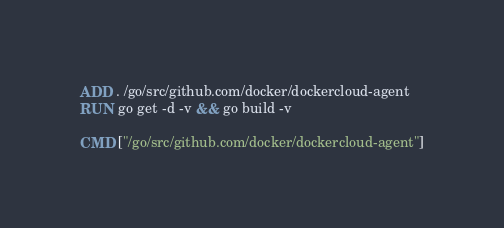Convert code to text. <code><loc_0><loc_0><loc_500><loc_500><_Dockerfile_>ADD . /go/src/github.com/docker/dockercloud-agent
RUN go get -d -v && go build -v

CMD ["/go/src/github.com/docker/dockercloud-agent"]
</code> 